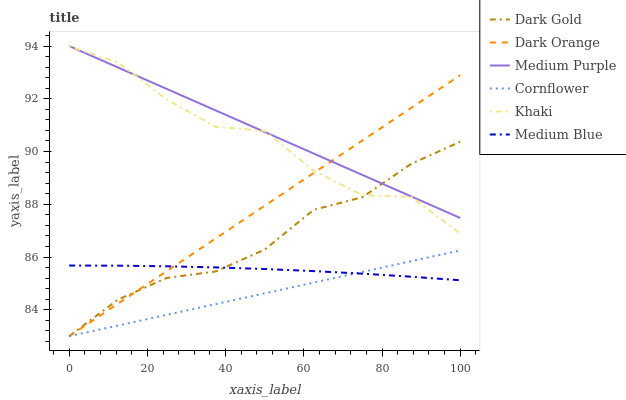Does Cornflower have the minimum area under the curve?
Answer yes or no. Yes. Does Medium Purple have the maximum area under the curve?
Answer yes or no. Yes. Does Khaki have the minimum area under the curve?
Answer yes or no. No. Does Khaki have the maximum area under the curve?
Answer yes or no. No. Is Dark Orange the smoothest?
Answer yes or no. Yes. Is Khaki the roughest?
Answer yes or no. Yes. Is Cornflower the smoothest?
Answer yes or no. No. Is Cornflower the roughest?
Answer yes or no. No. Does Dark Orange have the lowest value?
Answer yes or no. Yes. Does Khaki have the lowest value?
Answer yes or no. No. Does Medium Purple have the highest value?
Answer yes or no. Yes. Does Khaki have the highest value?
Answer yes or no. No. Is Medium Blue less than Khaki?
Answer yes or no. Yes. Is Medium Purple greater than Medium Blue?
Answer yes or no. Yes. Does Dark Gold intersect Medium Blue?
Answer yes or no. Yes. Is Dark Gold less than Medium Blue?
Answer yes or no. No. Is Dark Gold greater than Medium Blue?
Answer yes or no. No. Does Medium Blue intersect Khaki?
Answer yes or no. No. 